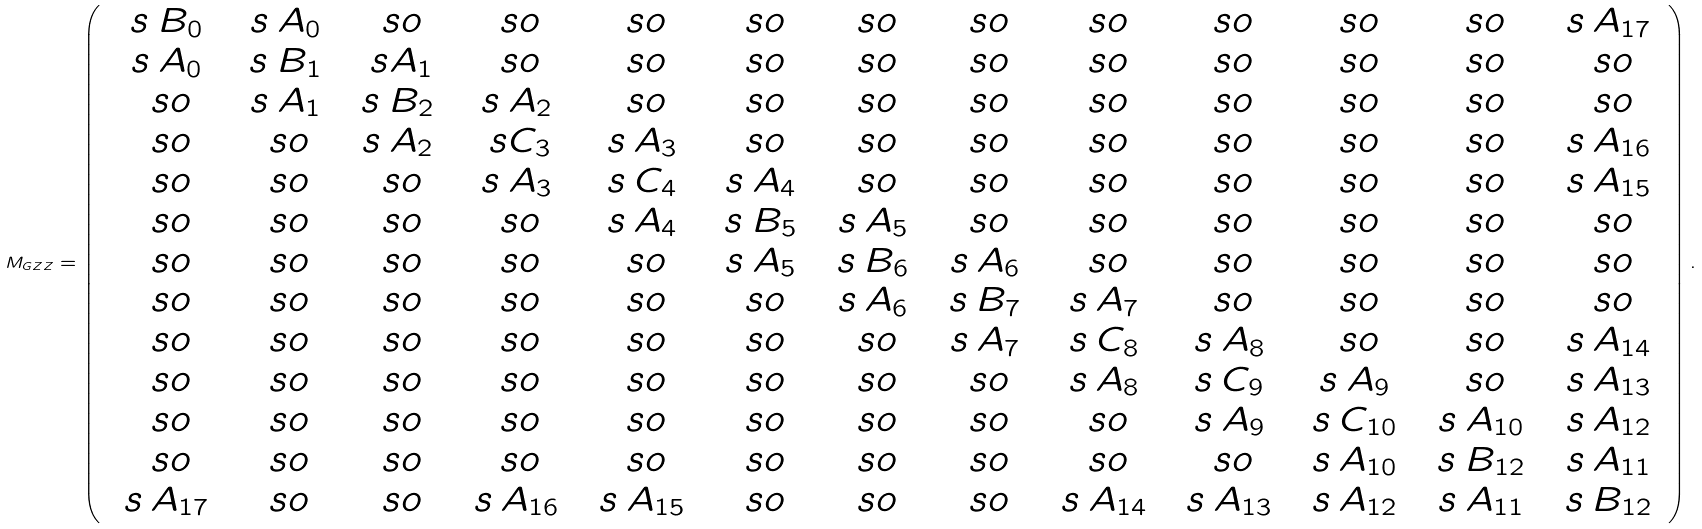<formula> <loc_0><loc_0><loc_500><loc_500>M _ { G Z Z } = \left ( \begin{array} { c c c c c c c c c c c c c } \ s { \, B _ { 0 } \, } & \ s { \, A _ { 0 } \, } & \ s o & \ s o & \ s o & \ s o & \ s o & \ s o & \ s o & \ s o & \ s o & \ s o & \ s { \, A _ { 1 7 } \, } \\ \ s { \, A _ { 0 } \, } & \ s { \, B _ { 1 } \, } & \ s { A _ { 1 } } & \ s o & \ s o & \ s o & \ s o & \ s o & \ s o & \ s o & \ s o & \ s o & \ s o \\ \ s o & \ s { \, A _ { 1 } \, } & \ s { \, B _ { 2 } \, } & \ s { \, A _ { 2 } \, } & \ s o & \ s o & \ s o & \ s o & \ s o & \ s o & \ s o & \ s o & \ s o \\ \ s o & \ s o & \ s { \, A _ { 2 } \, } & \ s { C _ { 3 } } & \ s { \, A _ { 3 } \, } & \ s o & \ s o & \ s o & \ s o & \ s o & \ s o & \ s o & \ s { \, A _ { 1 6 } \, } \\ \ s o & \ s o & \ s o & \ s { \, A _ { 3 } \, } & \ s { \, C _ { 4 } \, } & \ s { \, A _ { 4 } \, } & \ s o & \ s o & \ s o & \ s o & \ s o & \ s o & \ s { \, A _ { 1 5 } \, } \\ \ s o & \ s o & \ s o & \ s o & \ s { \, A _ { 4 } \, } & \ s { \, B _ { 5 } \, } & \ s { \, A _ { 5 } \, } & \ s o & \ s o & \ s o & \ s o & \ s o & \ s o \\ \ s o & \ s o & \ s o & \ s o & \ s o & \ s { \, A _ { 5 } \, } & \ s { \, B _ { 6 } \, } & \ s { \, A _ { 6 } \, } & \ s o & \ s o & \ s o & \ s o & \ s o \\ \ s o & \ s o & \ s o & \ s o & \ s o & \ s o & \ s { \, A _ { 6 } \, } & \ s { \, B _ { 7 } \, } & \ s { \, A _ { 7 } \, } & \ s o & \ s o & \ s o & \ s o \\ \ s o & \ s o & \ s o & \ s o & \ s o & \ s o & \ s o & \ s { \, A _ { 7 } \, } & \ s { \, C _ { 8 } \, } & \ s { \, A _ { 8 } \, } & \ s o & \ s o & \ s { \, A _ { 1 4 } \, } \\ \ s o & \ s o & \ s o & \ s o & \ s o & \ s o & \ s o & \ s o & \ s { \, A _ { 8 } \, } & \ s { \, C _ { 9 } \, } & \ s { \, A _ { 9 } \, } & \ s o & \ s { \, A _ { 1 3 } \, } \\ \ s o & \ s o & \ s o & \ s o & \ s o & \ s o & \ s o & \ s o & \ s o & \ s { \, A _ { 9 } \, } & \ s { \, C _ { 1 0 } \, } & \ s { \, A _ { 1 0 } \, } & \ s { \, A _ { 1 2 } \, } \\ \ s o & \ s o & \ s o & \ s o & \ s o & \ s o & \ s o & \ s o & \ s o & \ s o & \ s { \, A _ { 1 0 } \, } & \ s { \, B _ { 1 2 } \, } & \ s { \, A _ { 1 1 } \, } \\ \ s { \, A _ { 1 7 } \, } & \ s o & \ s o & \ s { \, A _ { 1 6 } \, } & \ s { \, A _ { 1 5 } \, } & \ s o & \ s o & \ s o & \ s { \, A _ { 1 4 } \, } & \ s { \, A _ { 1 3 } \, } & \ s { \, A _ { 1 2 } \, } & \ s { \, A _ { 1 1 } \, } & \ s { \, B _ { 1 2 } \, } \\ \end{array} \right ) .</formula> 